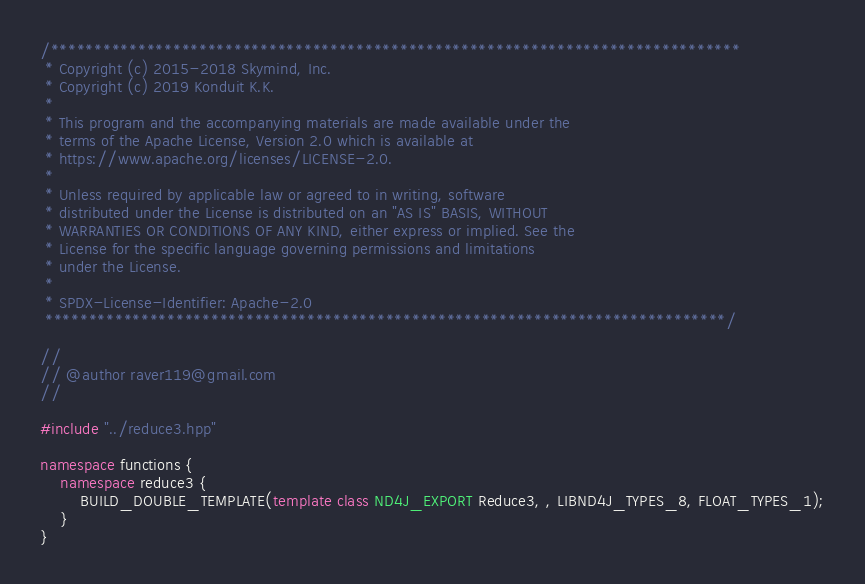Convert code to text. <code><loc_0><loc_0><loc_500><loc_500><_C++_>/*******************************************************************************
 * Copyright (c) 2015-2018 Skymind, Inc.
 * Copyright (c) 2019 Konduit K.K.
 *
 * This program and the accompanying materials are made available under the
 * terms of the Apache License, Version 2.0 which is available at
 * https://www.apache.org/licenses/LICENSE-2.0.
 *
 * Unless required by applicable law or agreed to in writing, software
 * distributed under the License is distributed on an "AS IS" BASIS, WITHOUT
 * WARRANTIES OR CONDITIONS OF ANY KIND, either express or implied. See the
 * License for the specific language governing permissions and limitations
 * under the License.
 *
 * SPDX-License-Identifier: Apache-2.0
 ******************************************************************************/

//
// @author raver119@gmail.com
//

#include "../reduce3.hpp"

namespace functions {
    namespace reduce3 {
        BUILD_DOUBLE_TEMPLATE(template class ND4J_EXPORT Reduce3, , LIBND4J_TYPES_8, FLOAT_TYPES_1);
    }
}</code> 